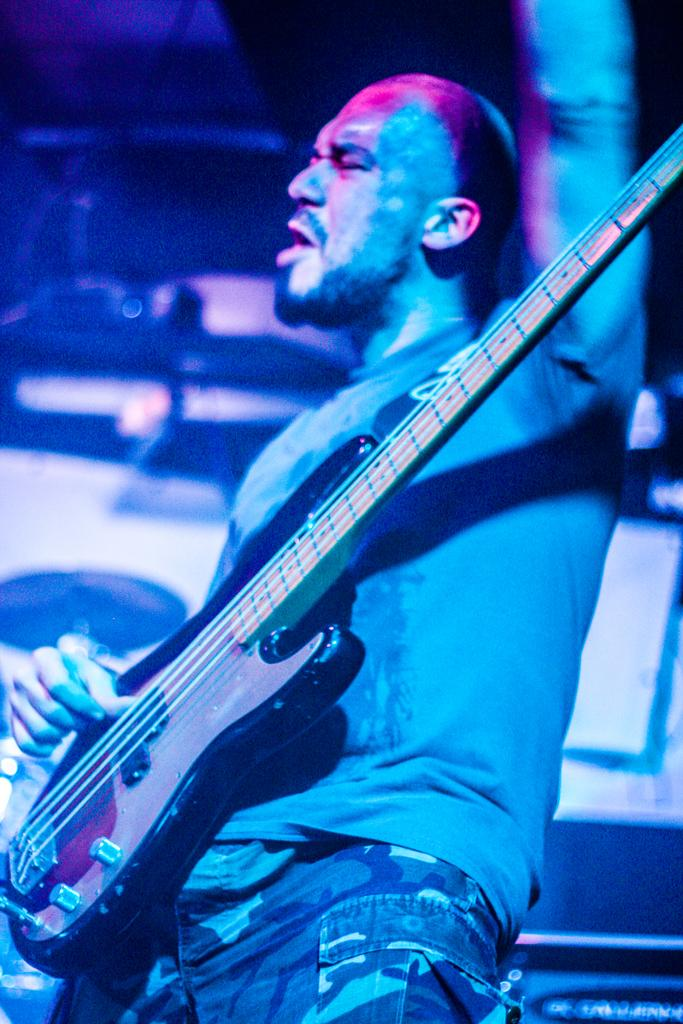What is the man in the image doing? The man is playing the guitar and singing. What instrument is the man holding in the image? The man is holding a guitar in the image. Can you describe the background of the image? The background of the image is blurry. Can you see any jars on the shelf in the image? There is no shelf or jar present in the image. What type of seashore can be seen in the background of the image? There is no seashore visible in the image; the background is blurry. 